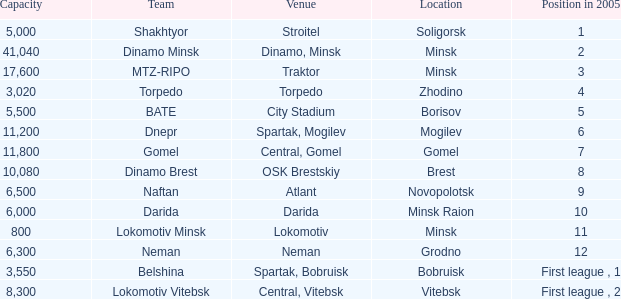Can you tell me the Venue that has the Position in 2005 of 8? OSK Brestskiy. 